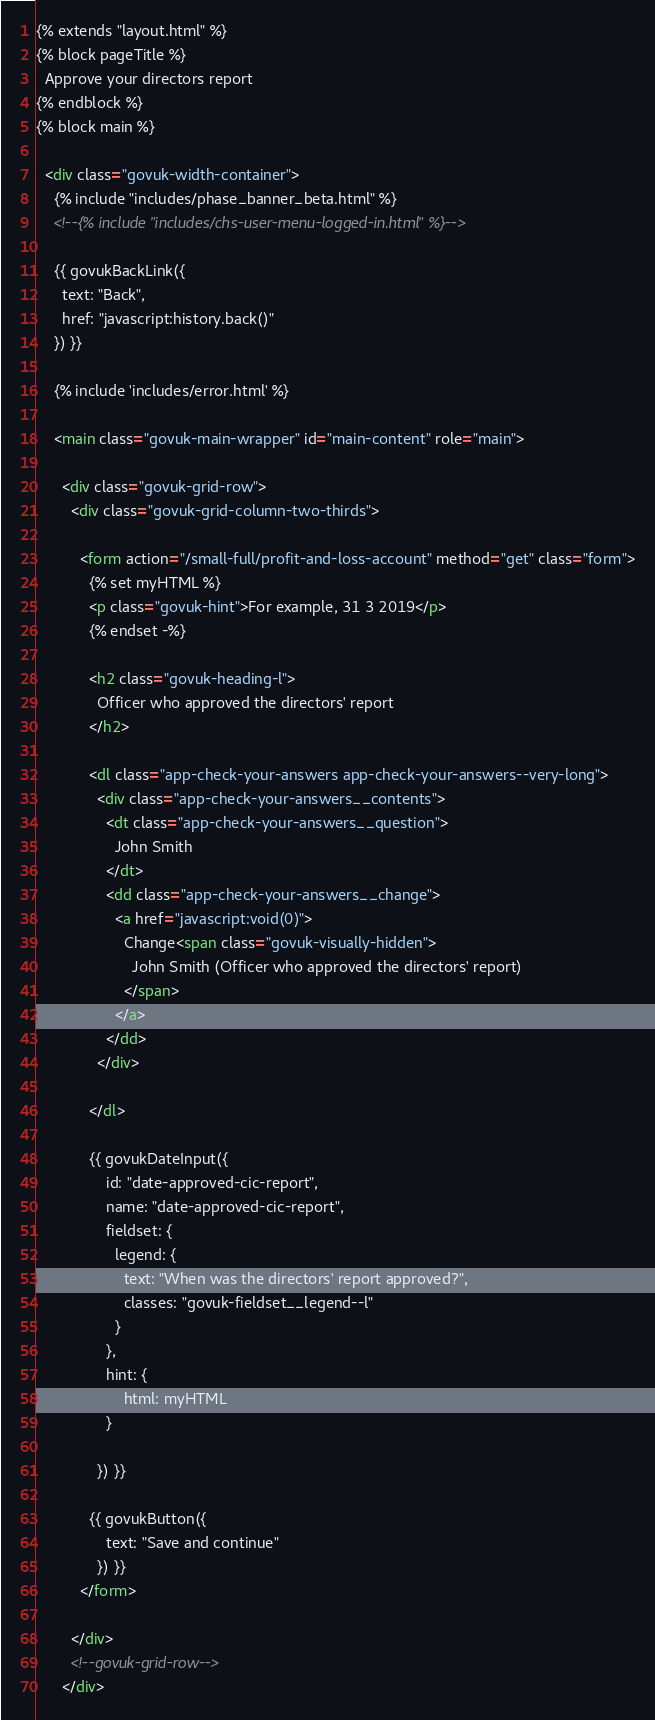<code> <loc_0><loc_0><loc_500><loc_500><_HTML_>{% extends "layout.html" %}
{% block pageTitle %}
  Approve your directors report
{% endblock %}
{% block main %}

  <div class="govuk-width-container">
    {% include "includes/phase_banner_beta.html" %}
    <!--{% include "includes/chs-user-menu-logged-in.html" %}-->

    {{ govukBackLink({
      text: "Back",
      href: "javascript:history.back()"
    }) }}

    {% include 'includes/error.html' %}

    <main class="govuk-main-wrapper" id="main-content" role="main">

      <div class="govuk-grid-row">
        <div class="govuk-grid-column-two-thirds">

          <form action="/small-full/profit-and-loss-account" method="get" class="form">
            {% set myHTML %}
            <p class="govuk-hint">For example, 31 3 2019</p>
            {% endset -%}

            <h2 class="govuk-heading-l">
              Officer who approved the directors' report
            </h2>

            <dl class="app-check-your-answers app-check-your-answers--very-long">
              <div class="app-check-your-answers__contents">
                <dt class="app-check-your-answers__question">
                  John Smith
                </dt>
                <dd class="app-check-your-answers__change">
                  <a href="javascript:void(0)">
                    Change<span class="govuk-visually-hidden">
                      John Smith (Officer who approved the directors' report)
                    </span>
                  </a>
                </dd>
              </div>

            </dl>

            {{ govukDateInput({
                id: "date-approved-cic-report",
                name: "date-approved-cic-report",
                fieldset: {
                  legend: {
                    text: "When was the directors' report approved?",
                    classes: "govuk-fieldset__legend--l"
                  }
                },
                hint: {
                    html: myHTML
                }

              }) }}

            {{ govukButton({
                text: "Save and continue"
              }) }}
          </form>

        </div>
        <!--govuk-grid-row-->
      </div></code> 